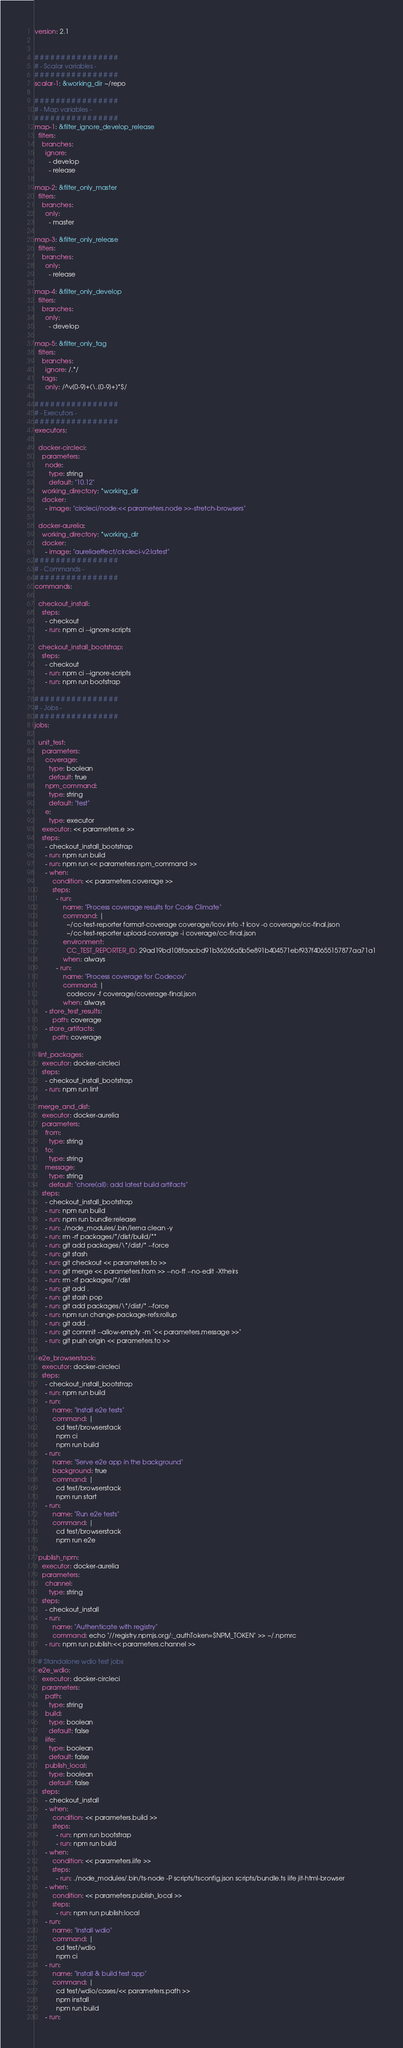<code> <loc_0><loc_0><loc_500><loc_500><_YAML_>version: 2.1


# # # # # # # # # # # # # # # #
# - Scalar variables -
# # # # # # # # # # # # # # # #
scalar-1: &working_dir ~/repo

# # # # # # # # # # # # # # # #
# - Map variables -
# # # # # # # # # # # # # # # #
map-1: &filter_ignore_develop_release
  filters:
    branches:
      ignore:
        - develop
        - release

map-2: &filter_only_master
  filters:
    branches:
      only:
        - master

map-3: &filter_only_release
  filters:
    branches:
      only:
        - release

map-4: &filter_only_develop
  filters:
    branches:
      only:
        - develop

map-5: &filter_only_tag
  filters:
    branches:
      ignore: /.*/
    tags:
      only: /^v[0-9]+(\.[0-9]+)*$/

# # # # # # # # # # # # # # # #
# - Executors -
# # # # # # # # # # # # # # # #
executors:

  docker-circleci:
    parameters:
      node:
        type: string
        default: "10.12"
    working_directory: *working_dir
    docker:
      - image: "circleci/node:<< parameters.node >>-stretch-browsers"

  docker-aurelia:
    working_directory: *working_dir
    docker:
      - image: "aureliaeffect/circleci-v2:latest"
# # # # # # # # # # # # # # # #
# - Commands -
# # # # # # # # # # # # # # # #
commands:

  checkout_install:
    steps:
      - checkout
      - run: npm ci --ignore-scripts

  checkout_install_bootstrap:
    steps:
      - checkout
      - run: npm ci --ignore-scripts
      - run: npm run bootstrap

# # # # # # # # # # # # # # # #
# - Jobs -
# # # # # # # # # # # # # # # #
jobs:

  unit_test:
    parameters:
      coverage:
        type: boolean
        default: true
      npm_command:
        type: string
        default: "test"
      e:
        type: executor
    executor: << parameters.e >>
    steps:
      - checkout_install_bootstrap
      - run: npm run build
      - run: npm run << parameters.npm_command >>
      - when:
          condition: << parameters.coverage >>
          steps:
            - run:
                name: "Process coverage results for Code Climate"
                command: |
                  ~/cc-test-reporter format-coverage coverage/lcov.info -t lcov -o coverage/cc-final.json
                  ~/cc-test-reporter upload-coverage -i coverage/cc-final.json
                environment:
                  CC_TEST_REPORTER_ID: 29ad19bd108faacbd91b36265a5b5e891b404571ebf937f40655157877aa71a1
                when: always
            - run:
                name: "Process coverage for Codecov"
                command: |
                  codecov -f coverage/coverage-final.json
                when: always
      - store_test_results:
          path: coverage
      - store_artifacts:
          path: coverage

  lint_packages:
    executor: docker-circleci
    steps:
      - checkout_install_bootstrap
      - run: npm run lint

  merge_and_dist:
    executor: docker-aurelia
    parameters:
      from:
        type: string
      to:
        type: string
      message:
        type: string
        default: "chore(all): add latest build artifacts"
    steps:
      - checkout_install_bootstrap
      - run: npm run build
      - run: npm run bundle:release
      - run: ./node_modules/.bin/lerna clean -y
      - run: rm -rf packages/*/dist/build/**
      - run: git add packages/\*/dist/* --force
      - run: git stash
      - run: git checkout << parameters.to >>
      - run: git merge << parameters.from >> --no-ff --no-edit -Xtheirs
      - run: rm -rf packages/*/dist
      - run: git add .
      - run: git stash pop
      - run: git add packages/\*/dist/* --force
      - run: npm run change-package-refs:rollup
      - run: git add .
      - run: git commit --allow-empty -m "<< parameters.message >>"
      - run: git push origin << parameters.to >>

  e2e_browserstack:
    executor: docker-circleci
    steps:
      - checkout_install_bootstrap
      - run: npm run build
      - run:
          name: "Install e2e tests"
          command: |
            cd test/browserstack
            npm ci
            npm run build
      - run:
          name: "Serve e2e app in the background"
          background: true
          command: |
            cd test/browserstack
            npm run start
      - run:
          name: "Run e2e tests"
          command: |
            cd test/browserstack
            npm run e2e

  publish_npm:
    executor: docker-aurelia
    parameters:
      channel:
        type: string
    steps:
      - checkout_install
      - run:
          name: "Authenticate with registry"
          command: echo "//registry.npmjs.org/:_authToken=$NPM_TOKEN" >> ~/.npmrc
      - run: npm run publish:<< parameters.channel >>

  # Standalone wdio test jobs
  e2e_wdio:
    executor: docker-circleci
    parameters:
      path:
        type: string
      build:
        type: boolean
        default: false
      iife:
        type: boolean
        default: false
      publish_local:
        type: boolean
        default: false
    steps:
      - checkout_install
      - when:
          condition: << parameters.build >>
          steps:
            - run: npm run bootstrap
            - run: npm run build
      - when:
          condition: << parameters.iife >>
          steps:
            - run: ./node_modules/.bin/ts-node -P scripts/tsconfig.json scripts/bundle.ts iife jit-html-browser
      - when:
          condition: << parameters.publish_local >>
          steps:
            - run: npm run publish:local
      - run:
          name: "Install wdio"
          command: |
            cd test/wdio
            npm ci
      - run:
          name: "Install & build test app"
          command: |
            cd test/wdio/cases/<< parameters.path >>
            npm install
            npm run build
      - run:</code> 